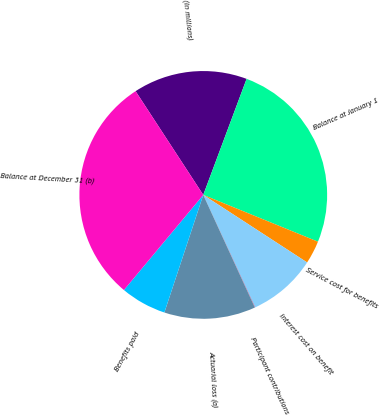Convert chart to OTSL. <chart><loc_0><loc_0><loc_500><loc_500><pie_chart><fcel>(In millions)<fcel>Balance at January 1<fcel>Service cost for benefits<fcel>Interest cost on benefit<fcel>Participant contributions<fcel>Actuarial loss (a)<fcel>Benefits paid<fcel>Balance at December 31 (b)<nl><fcel>14.89%<fcel>25.48%<fcel>3.01%<fcel>8.95%<fcel>0.04%<fcel>11.92%<fcel>5.98%<fcel>29.74%<nl></chart> 